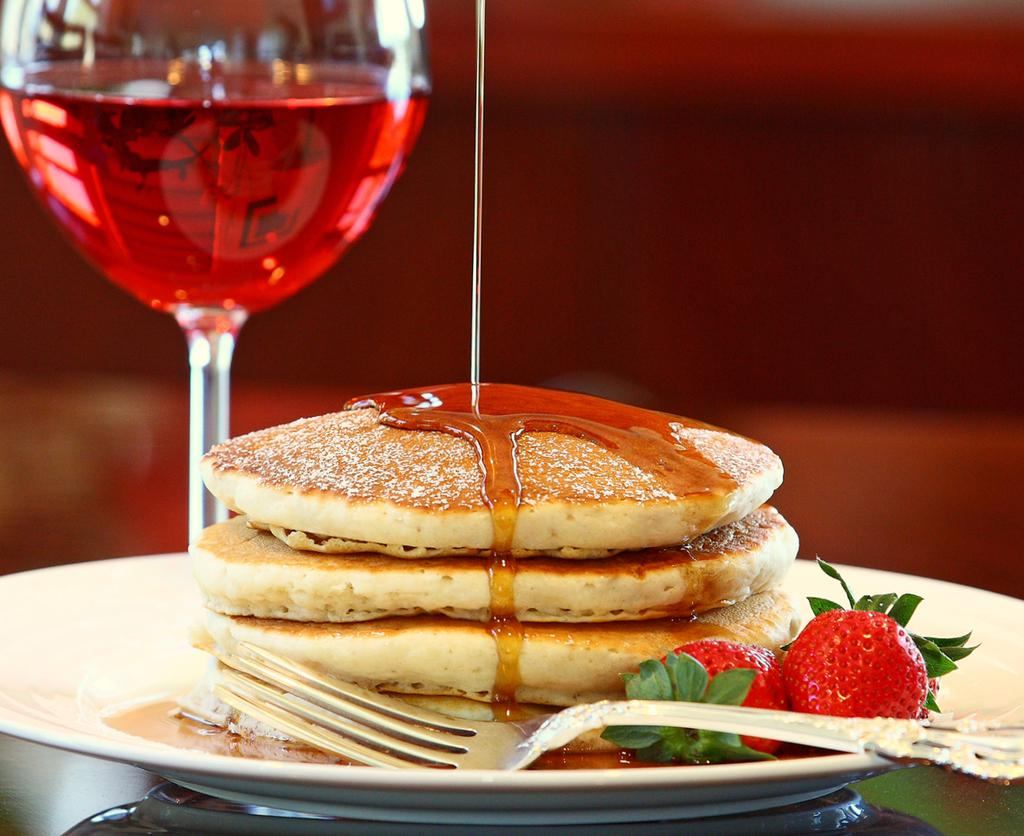What piece of furniture is present in the image? There is a table in the image. What is placed on the table? There is a plate on the table. What is on the plate? There are food items in the plate. What utensil can be seen in the image? There is a spoon in the image. What type of container is present in the image? There is a glass in the image. What is inside the glass? There is a liquid in the glass. What type of view can be seen through the bit in the image? There is no bit present in the image, and therefore no view can be seen through it. 